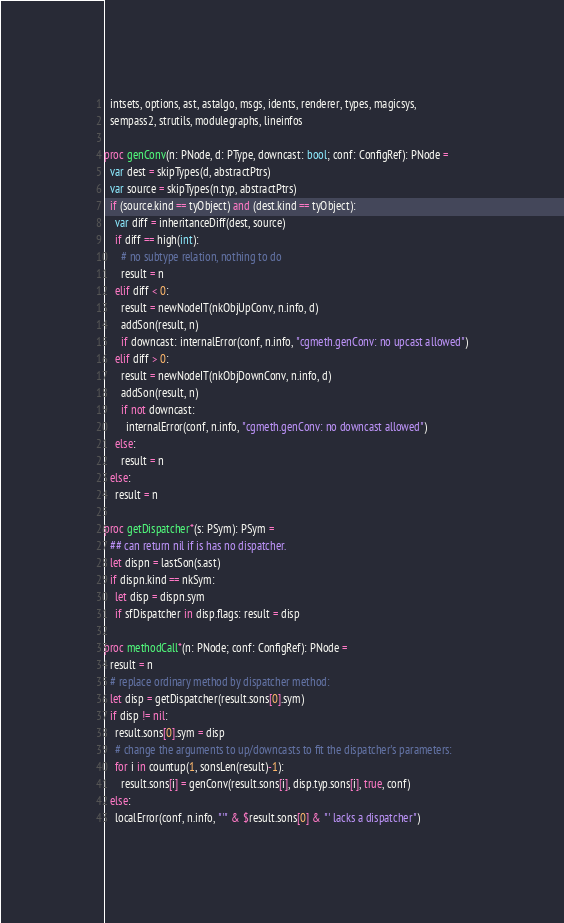Convert code to text. <code><loc_0><loc_0><loc_500><loc_500><_Nim_>  intsets, options, ast, astalgo, msgs, idents, renderer, types, magicsys,
  sempass2, strutils, modulegraphs, lineinfos

proc genConv(n: PNode, d: PType, downcast: bool; conf: ConfigRef): PNode =
  var dest = skipTypes(d, abstractPtrs)
  var source = skipTypes(n.typ, abstractPtrs)
  if (source.kind == tyObject) and (dest.kind == tyObject):
    var diff = inheritanceDiff(dest, source)
    if diff == high(int):
      # no subtype relation, nothing to do
      result = n
    elif diff < 0:
      result = newNodeIT(nkObjUpConv, n.info, d)
      addSon(result, n)
      if downcast: internalError(conf, n.info, "cgmeth.genConv: no upcast allowed")
    elif diff > 0:
      result = newNodeIT(nkObjDownConv, n.info, d)
      addSon(result, n)
      if not downcast:
        internalError(conf, n.info, "cgmeth.genConv: no downcast allowed")
    else:
      result = n
  else:
    result = n

proc getDispatcher*(s: PSym): PSym =
  ## can return nil if is has no dispatcher.
  let dispn = lastSon(s.ast)
  if dispn.kind == nkSym:
    let disp = dispn.sym
    if sfDispatcher in disp.flags: result = disp

proc methodCall*(n: PNode; conf: ConfigRef): PNode =
  result = n
  # replace ordinary method by dispatcher method:
  let disp = getDispatcher(result.sons[0].sym)
  if disp != nil:
    result.sons[0].sym = disp
    # change the arguments to up/downcasts to fit the dispatcher's parameters:
    for i in countup(1, sonsLen(result)-1):
      result.sons[i] = genConv(result.sons[i], disp.typ.sons[i], true, conf)
  else:
    localError(conf, n.info, "'" & $result.sons[0] & "' lacks a dispatcher")
</code> 